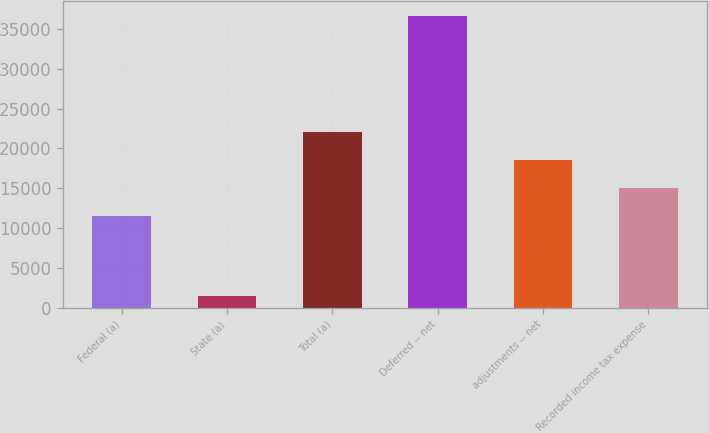<chart> <loc_0><loc_0><loc_500><loc_500><bar_chart><fcel>Federal (a)<fcel>State (a)<fcel>Total (a)<fcel>Deferred -- net<fcel>adjustments -- net<fcel>Recorded income tax expense<nl><fcel>11535<fcel>1503<fcel>22079.7<fcel>36652<fcel>18564.8<fcel>15049.9<nl></chart> 